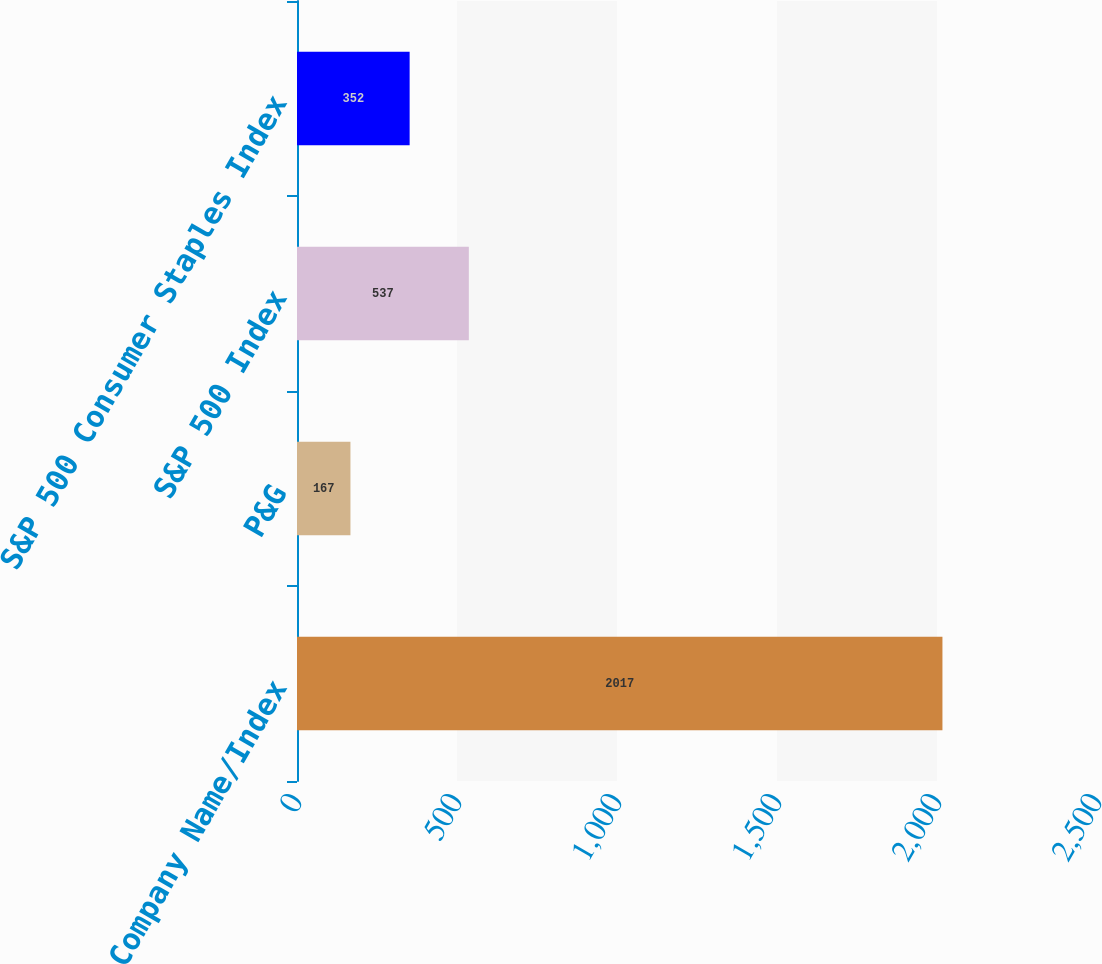Convert chart. <chart><loc_0><loc_0><loc_500><loc_500><bar_chart><fcel>Company Name/Index<fcel>P&G<fcel>S&P 500 Index<fcel>S&P 500 Consumer Staples Index<nl><fcel>2017<fcel>167<fcel>537<fcel>352<nl></chart> 